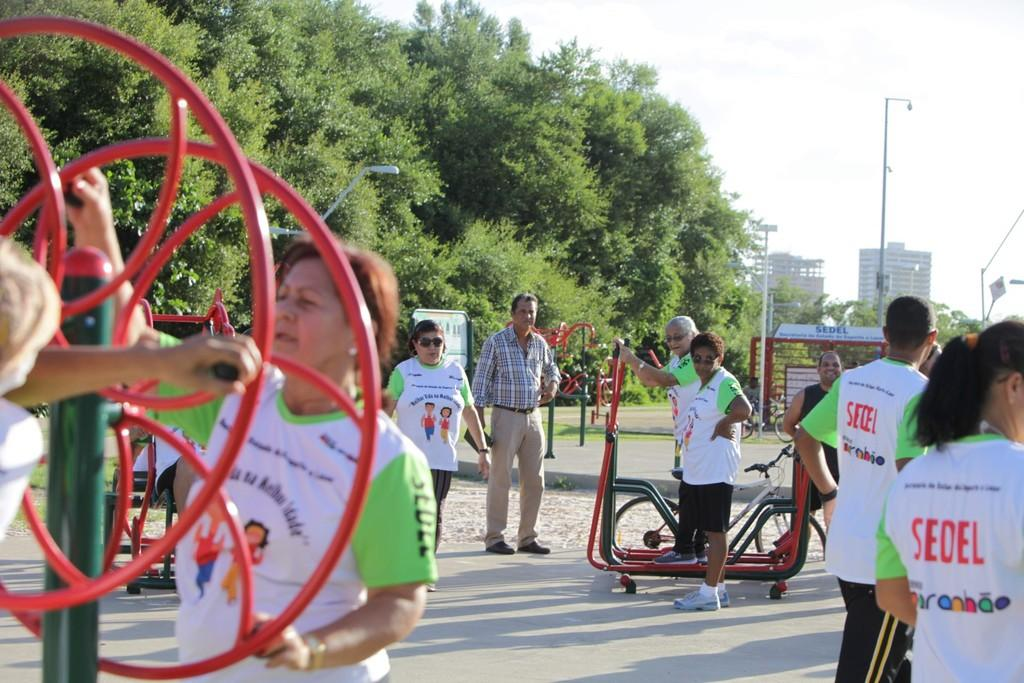Who or what can be seen in the image? There are people in the image. What are the people using or interacting with in the image? There are bicycles and playing objects in the image. What type of structures are visible in the image? There are buildings in the image. What type of natural elements are present in the image? There are trees in the image. What type of man-made structures are present in the image? There are poles in the image. What type of lighting is present in the image? There are lights in the image. What part of the natural environment is visible in the image? The sky is visible in the image. What type of lip can be seen on the bicycle in the image? There is no lip present on the bicycle in the image. What type of ornament is hanging from the trees in the image? There are no ornaments hanging from the trees in the image. 